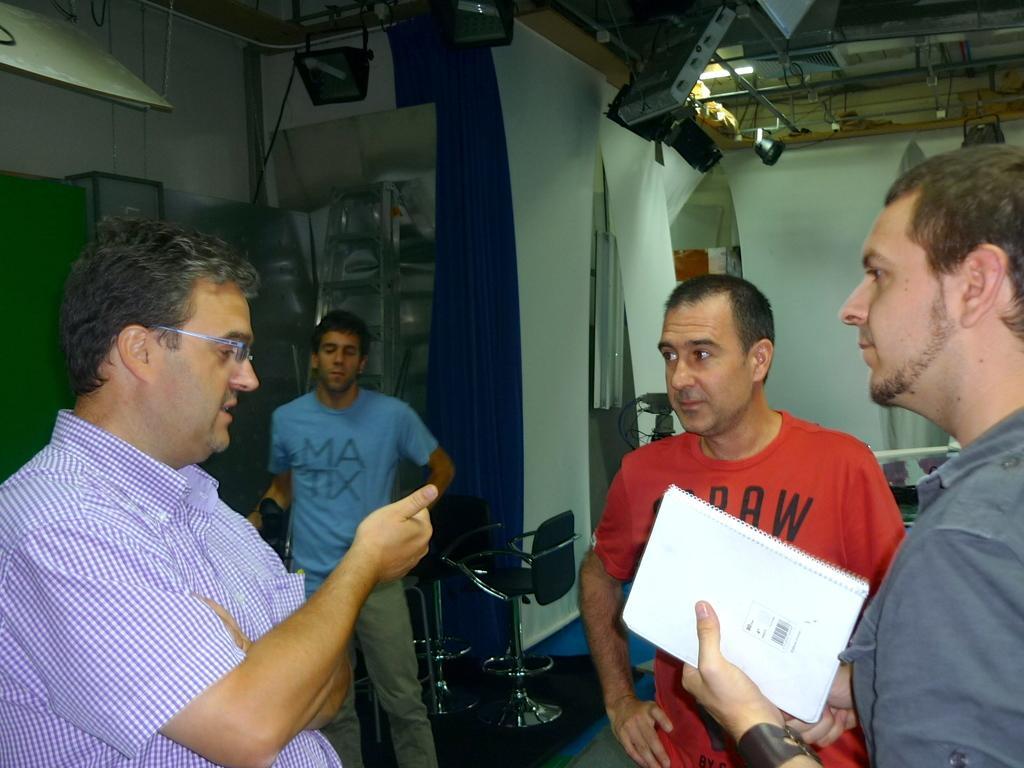How would you summarize this image in a sentence or two? In this picture we can see four men standing were a man holding a book with his hand, chairs, curtains, walls and in the background we can see some objects. 